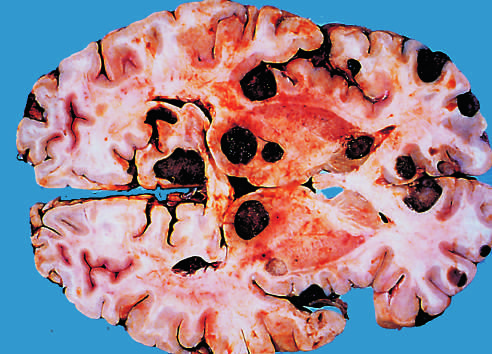what is due to the presence of melanin?
Answer the question using a single word or phrase. The dark color of the tumor nodules 